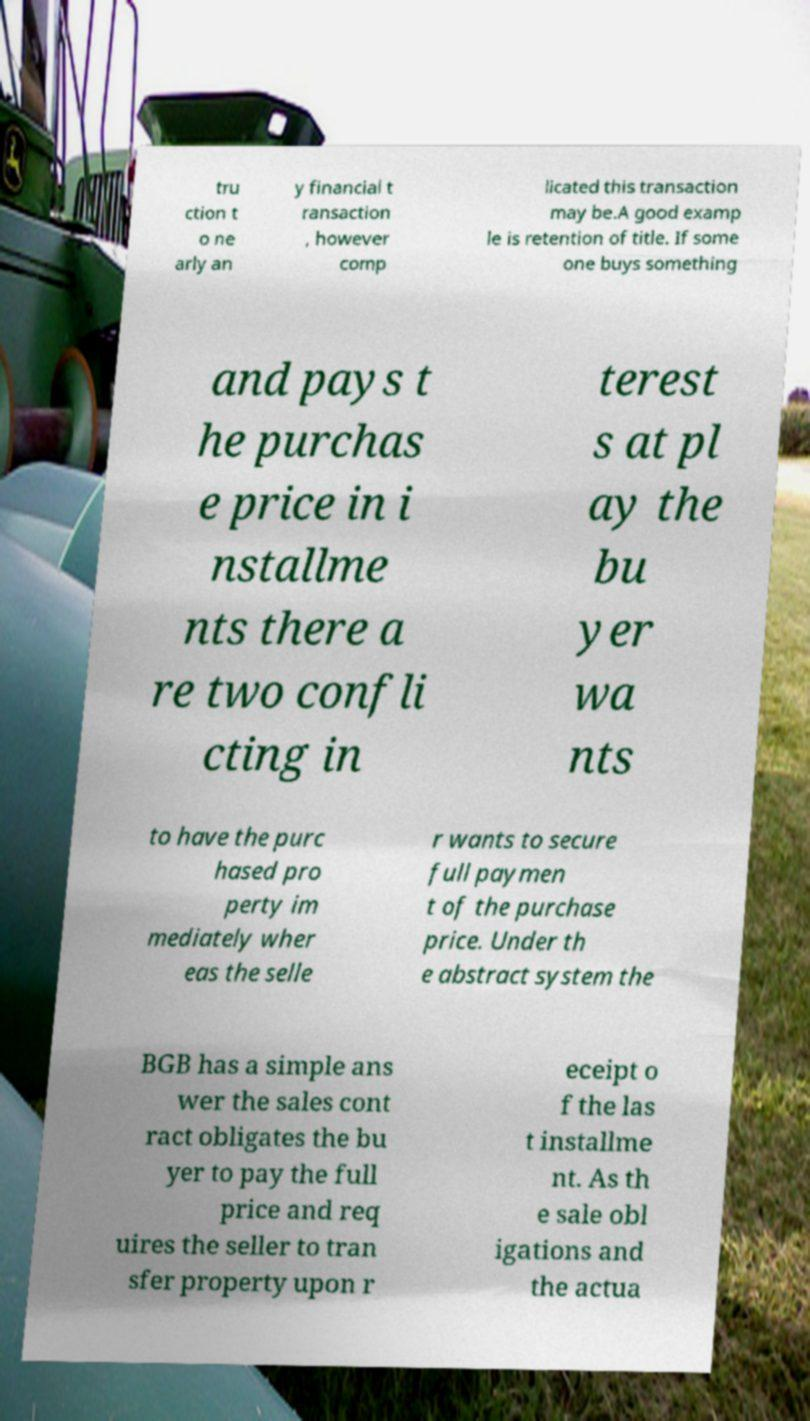For documentation purposes, I need the text within this image transcribed. Could you provide that? tru ction t o ne arly an y financial t ransaction , however comp licated this transaction may be.A good examp le is retention of title. If some one buys something and pays t he purchas e price in i nstallme nts there a re two confli cting in terest s at pl ay the bu yer wa nts to have the purc hased pro perty im mediately wher eas the selle r wants to secure full paymen t of the purchase price. Under th e abstract system the BGB has a simple ans wer the sales cont ract obligates the bu yer to pay the full price and req uires the seller to tran sfer property upon r eceipt o f the las t installme nt. As th e sale obl igations and the actua 